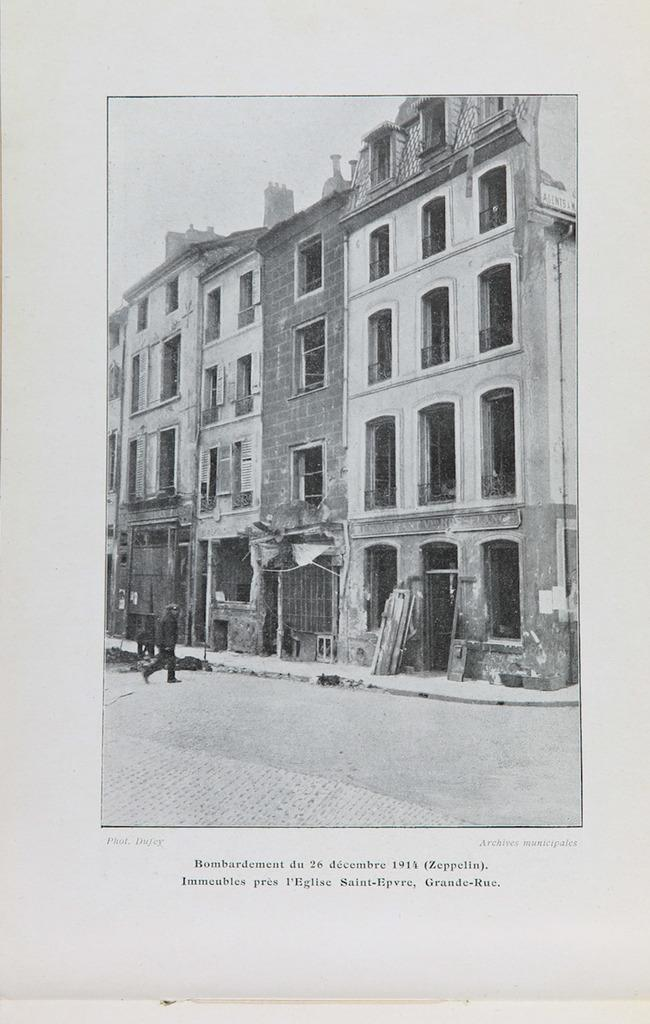What is the main subject of the poster in the image? The poster depicts a person standing on the road. What type of background is visible in the image? There is a building in the image. What is the color scheme of the image? The image is in black and white color. What type of jeans is the person wearing in the image? There is no information about the person's clothing in the image, as it is in black and white color. How does the sheet affect the digestion of the person in the image? There is no sheet or mention of digestion in the image; it only features a person standing on the road and a building in the background. 